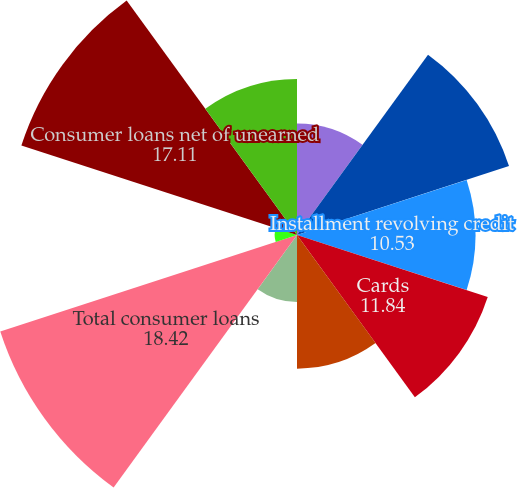<chart> <loc_0><loc_0><loc_500><loc_500><pie_chart><fcel>In millions of dollars<fcel>Mortgage and real estate (1)<fcel>Installment revolving credit<fcel>Cards<fcel>Commercial and industrial<fcel>Lease financing<fcel>Total consumer loans<fcel>Unearned income (2)<fcel>Consumer loans net of unearned<fcel>Loans to financial<nl><fcel>6.58%<fcel>13.16%<fcel>10.53%<fcel>11.84%<fcel>7.89%<fcel>3.95%<fcel>18.42%<fcel>1.32%<fcel>17.11%<fcel>9.21%<nl></chart> 